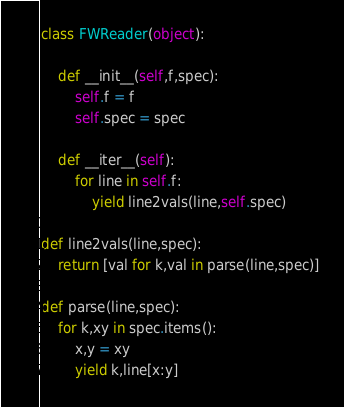Convert code to text. <code><loc_0><loc_0><loc_500><loc_500><_Python_>class FWReader(object):

    def __init__(self,f,spec):
        self.f = f
        self.spec = spec

    def __iter__(self):
        for line in self.f:
            yield line2vals(line,self.spec)

def line2vals(line,spec):
    return [val for k,val in parse(line,spec)]

def parse(line,spec):
    for k,xy in spec.items():
        x,y = xy
        yield k,line[x:y]

</code> 